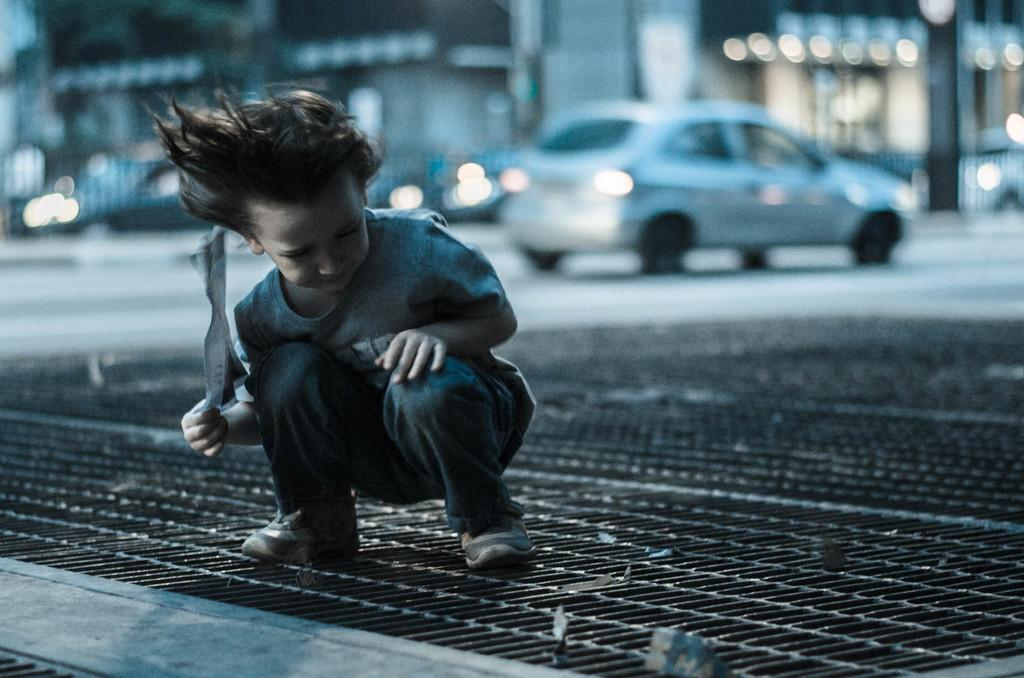What is the main subject of the image? The main subject of the image is a kid. Where is the kid located in the image? The kid is in the center of the image. What is the kid standing on? The kid is on a mesh. What is the kid holding in the image? The kid is holding an object. What can be seen in the background of the image? There is a vehicle, lights, and other objects visible in the background of the image. What type of plantation can be seen in the background of the image? There is no plantation present in the image; the background features a vehicle, lights, and other objects. Is the kid a spy in the image? There is no indication in the image that the kid is a spy, as the image does not provide any context or information about their activities or intentions. 